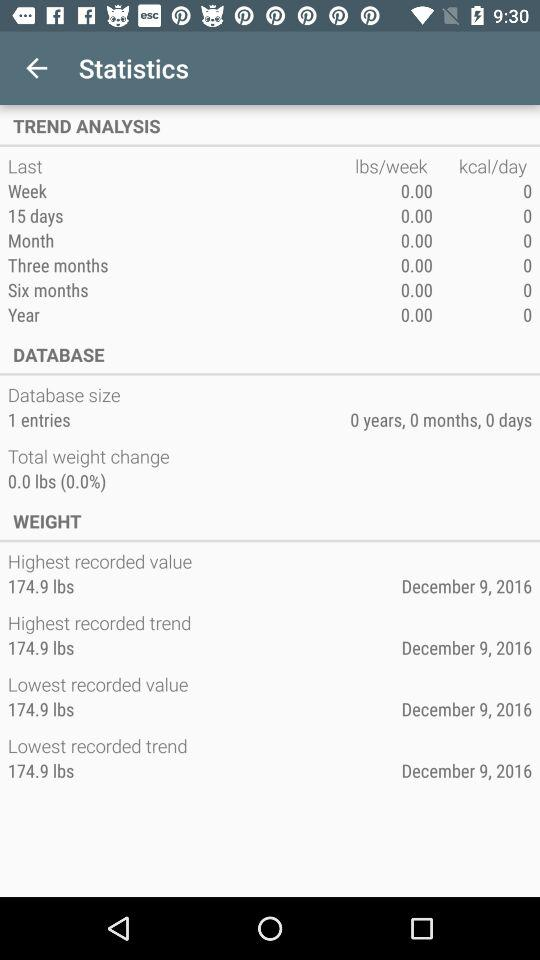What is the highest recorded trend? The highest recorded trend is 174.9 lbs. 